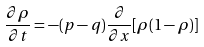Convert formula to latex. <formula><loc_0><loc_0><loc_500><loc_500>\frac { \partial \rho } { \partial t } = - ( p - q ) \frac { \partial } { \partial x } [ \rho ( 1 - \rho ) ]</formula> 